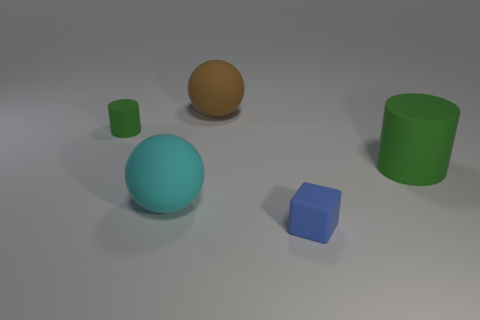Add 2 cyan matte spheres. How many objects exist? 7 Subtract all cyan balls. How many balls are left? 1 Subtract 1 balls. How many balls are left? 1 Subtract all green rubber objects. Subtract all tiny things. How many objects are left? 1 Add 2 matte cylinders. How many matte cylinders are left? 4 Add 2 green matte cylinders. How many green matte cylinders exist? 4 Subtract 1 blue cubes. How many objects are left? 4 Subtract all cylinders. How many objects are left? 3 Subtract all purple cylinders. Subtract all cyan balls. How many cylinders are left? 2 Subtract all green blocks. How many brown balls are left? 1 